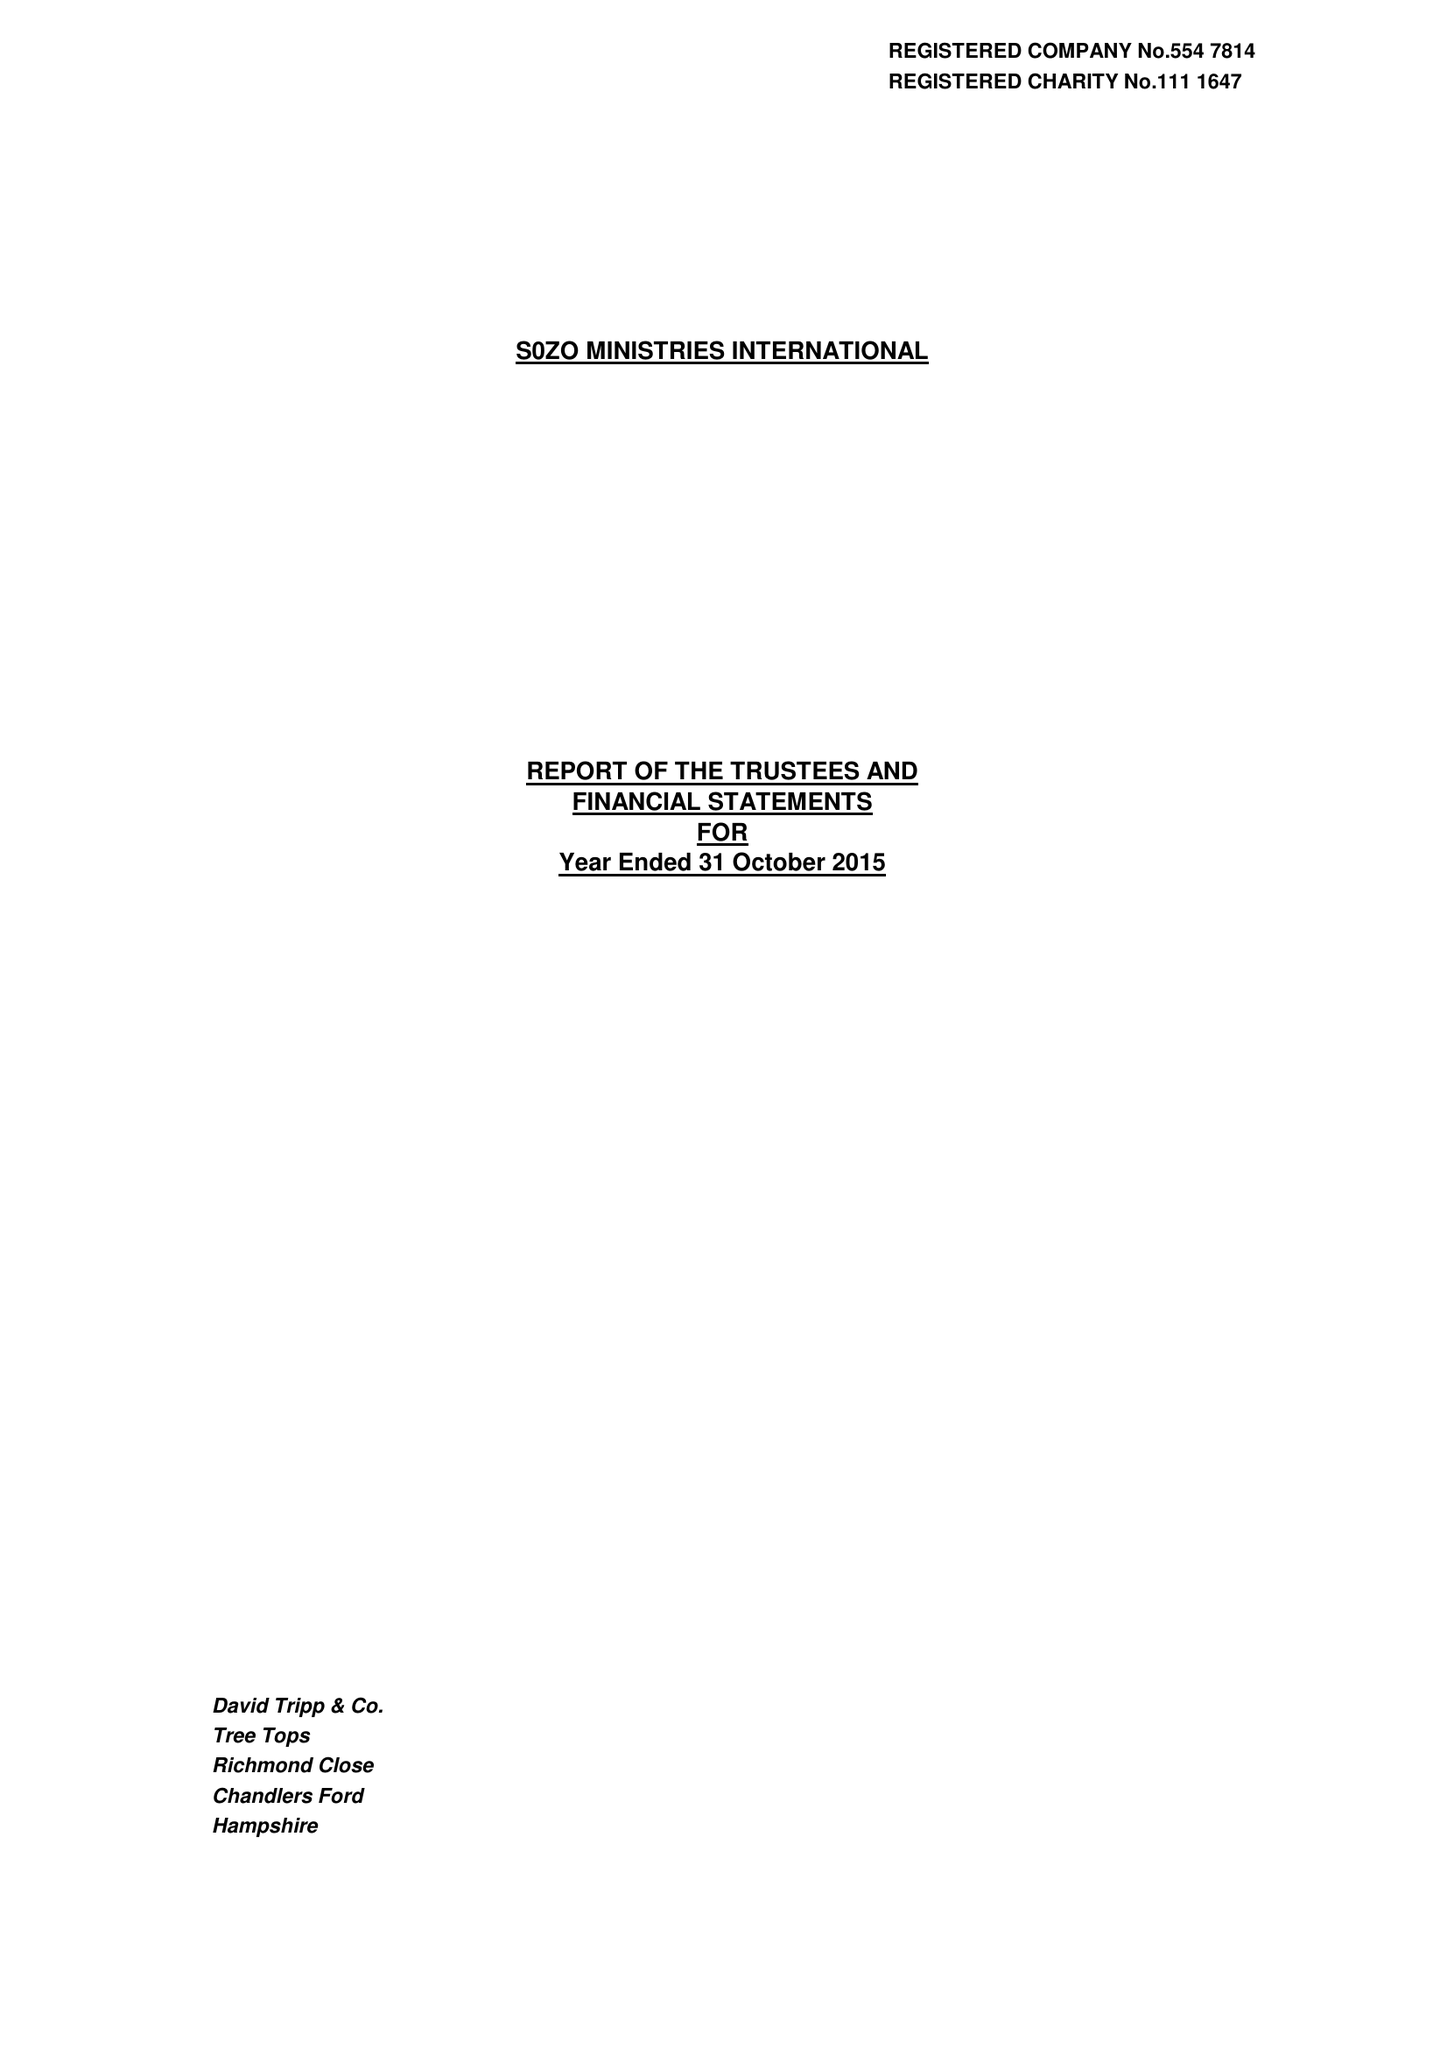What is the value for the charity_number?
Answer the question using a single word or phrase. 1111647 